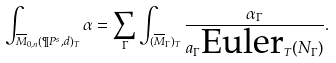<formula> <loc_0><loc_0><loc_500><loc_500>\int _ { { \overline { M } } _ { 0 , n } ( \P P ^ { s } , d ) _ { T } } \alpha = \sum _ { \Gamma } \int _ { ( { \overline { M } } _ { \Gamma } ) _ { T } } \frac { \alpha _ { \Gamma } } { a _ { \Gamma } \text {Euler} _ { T } ( N _ { \Gamma } ) } .</formula> 